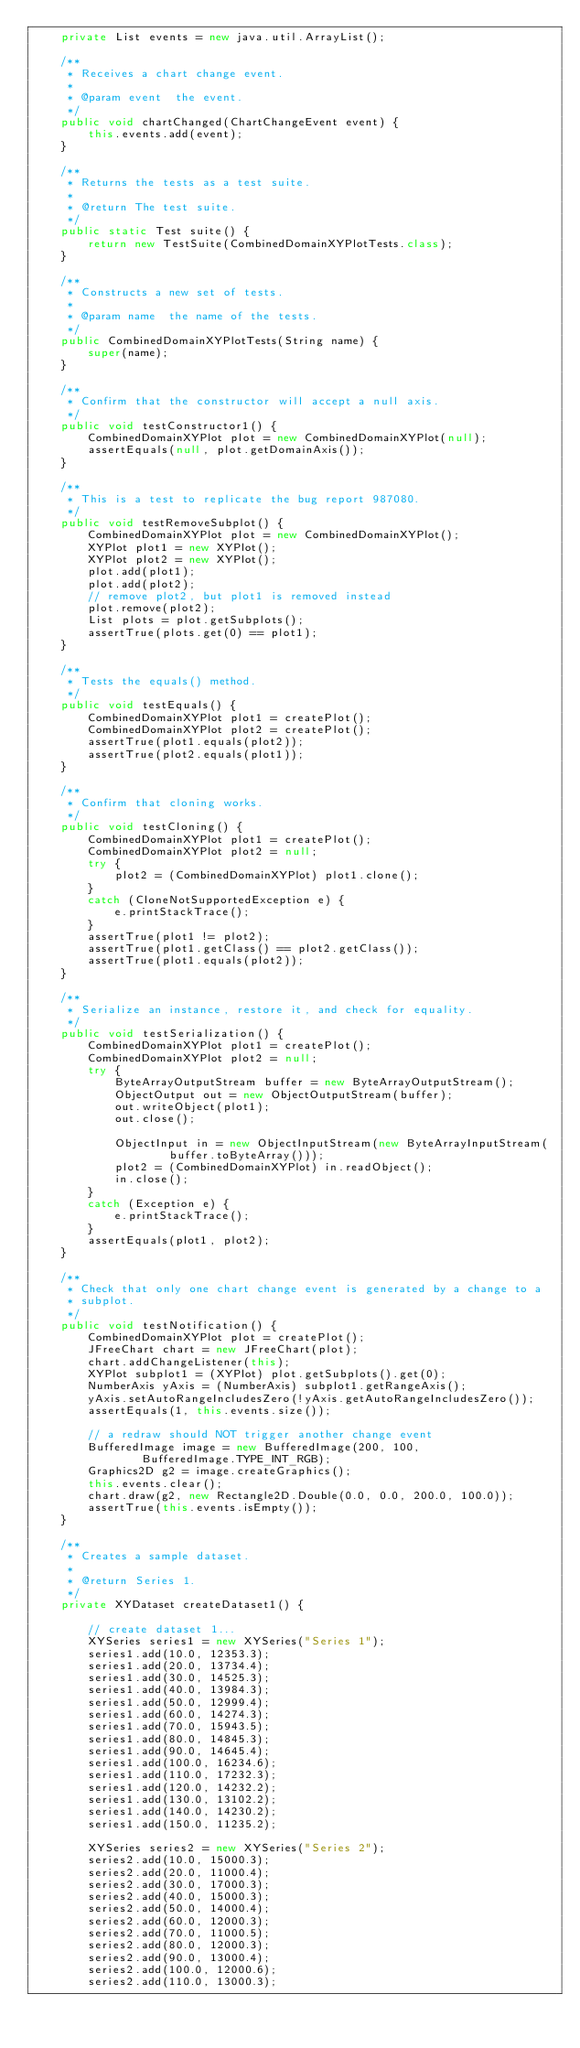<code> <loc_0><loc_0><loc_500><loc_500><_Java_>    private List events = new java.util.ArrayList();

    /**
     * Receives a chart change event.
     *
     * @param event  the event.
     */
    public void chartChanged(ChartChangeEvent event) {
        this.events.add(event);
    }

    /**
     * Returns the tests as a test suite.
     *
     * @return The test suite.
     */
    public static Test suite() {
        return new TestSuite(CombinedDomainXYPlotTests.class);
    }

    /**
     * Constructs a new set of tests.
     *
     * @param name  the name of the tests.
     */
    public CombinedDomainXYPlotTests(String name) {
        super(name);
    }

    /**
     * Confirm that the constructor will accept a null axis.
     */
    public void testConstructor1() {
        CombinedDomainXYPlot plot = new CombinedDomainXYPlot(null);
        assertEquals(null, plot.getDomainAxis());
    }

    /**
     * This is a test to replicate the bug report 987080.
     */
    public void testRemoveSubplot() {
        CombinedDomainXYPlot plot = new CombinedDomainXYPlot();
        XYPlot plot1 = new XYPlot();
        XYPlot plot2 = new XYPlot();
        plot.add(plot1);
        plot.add(plot2);
        // remove plot2, but plot1 is removed instead
        plot.remove(plot2);
        List plots = plot.getSubplots();
        assertTrue(plots.get(0) == plot1);
    }

    /**
     * Tests the equals() method.
     */
    public void testEquals() {
        CombinedDomainXYPlot plot1 = createPlot();
        CombinedDomainXYPlot plot2 = createPlot();
        assertTrue(plot1.equals(plot2));
        assertTrue(plot2.equals(plot1));
    }

    /**
     * Confirm that cloning works.
     */
    public void testCloning() {
        CombinedDomainXYPlot plot1 = createPlot();
        CombinedDomainXYPlot plot2 = null;
        try {
            plot2 = (CombinedDomainXYPlot) plot1.clone();
        }
        catch (CloneNotSupportedException e) {
            e.printStackTrace();
        }
        assertTrue(plot1 != plot2);
        assertTrue(plot1.getClass() == plot2.getClass());
        assertTrue(plot1.equals(plot2));
    }

    /**
     * Serialize an instance, restore it, and check for equality.
     */
    public void testSerialization() {
        CombinedDomainXYPlot plot1 = createPlot();
        CombinedDomainXYPlot plot2 = null;
        try {
            ByteArrayOutputStream buffer = new ByteArrayOutputStream();
            ObjectOutput out = new ObjectOutputStream(buffer);
            out.writeObject(plot1);
            out.close();

            ObjectInput in = new ObjectInputStream(new ByteArrayInputStream(
                    buffer.toByteArray()));
            plot2 = (CombinedDomainXYPlot) in.readObject();
            in.close();
        }
        catch (Exception e) {
            e.printStackTrace();
        }
        assertEquals(plot1, plot2);
    }

    /**
     * Check that only one chart change event is generated by a change to a
     * subplot.
     */
    public void testNotification() {
        CombinedDomainXYPlot plot = createPlot();
        JFreeChart chart = new JFreeChart(plot);
        chart.addChangeListener(this);
        XYPlot subplot1 = (XYPlot) plot.getSubplots().get(0);
        NumberAxis yAxis = (NumberAxis) subplot1.getRangeAxis();
        yAxis.setAutoRangeIncludesZero(!yAxis.getAutoRangeIncludesZero());
        assertEquals(1, this.events.size());

        // a redraw should NOT trigger another change event
        BufferedImage image = new BufferedImage(200, 100,
                BufferedImage.TYPE_INT_RGB);
        Graphics2D g2 = image.createGraphics();
        this.events.clear();
        chart.draw(g2, new Rectangle2D.Double(0.0, 0.0, 200.0, 100.0));
        assertTrue(this.events.isEmpty());
    }

    /**
     * Creates a sample dataset.
     *
     * @return Series 1.
     */
    private XYDataset createDataset1() {

        // create dataset 1...
        XYSeries series1 = new XYSeries("Series 1");
        series1.add(10.0, 12353.3);
        series1.add(20.0, 13734.4);
        series1.add(30.0, 14525.3);
        series1.add(40.0, 13984.3);
        series1.add(50.0, 12999.4);
        series1.add(60.0, 14274.3);
        series1.add(70.0, 15943.5);
        series1.add(80.0, 14845.3);
        series1.add(90.0, 14645.4);
        series1.add(100.0, 16234.6);
        series1.add(110.0, 17232.3);
        series1.add(120.0, 14232.2);
        series1.add(130.0, 13102.2);
        series1.add(140.0, 14230.2);
        series1.add(150.0, 11235.2);

        XYSeries series2 = new XYSeries("Series 2");
        series2.add(10.0, 15000.3);
        series2.add(20.0, 11000.4);
        series2.add(30.0, 17000.3);
        series2.add(40.0, 15000.3);
        series2.add(50.0, 14000.4);
        series2.add(60.0, 12000.3);
        series2.add(70.0, 11000.5);
        series2.add(80.0, 12000.3);
        series2.add(90.0, 13000.4);
        series2.add(100.0, 12000.6);
        series2.add(110.0, 13000.3);</code> 